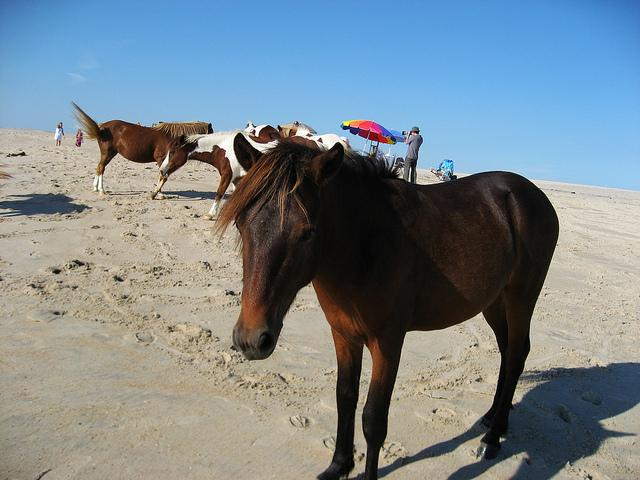How many horses are countable on the beach? Please explain your reasoning. five. There are five horses. 